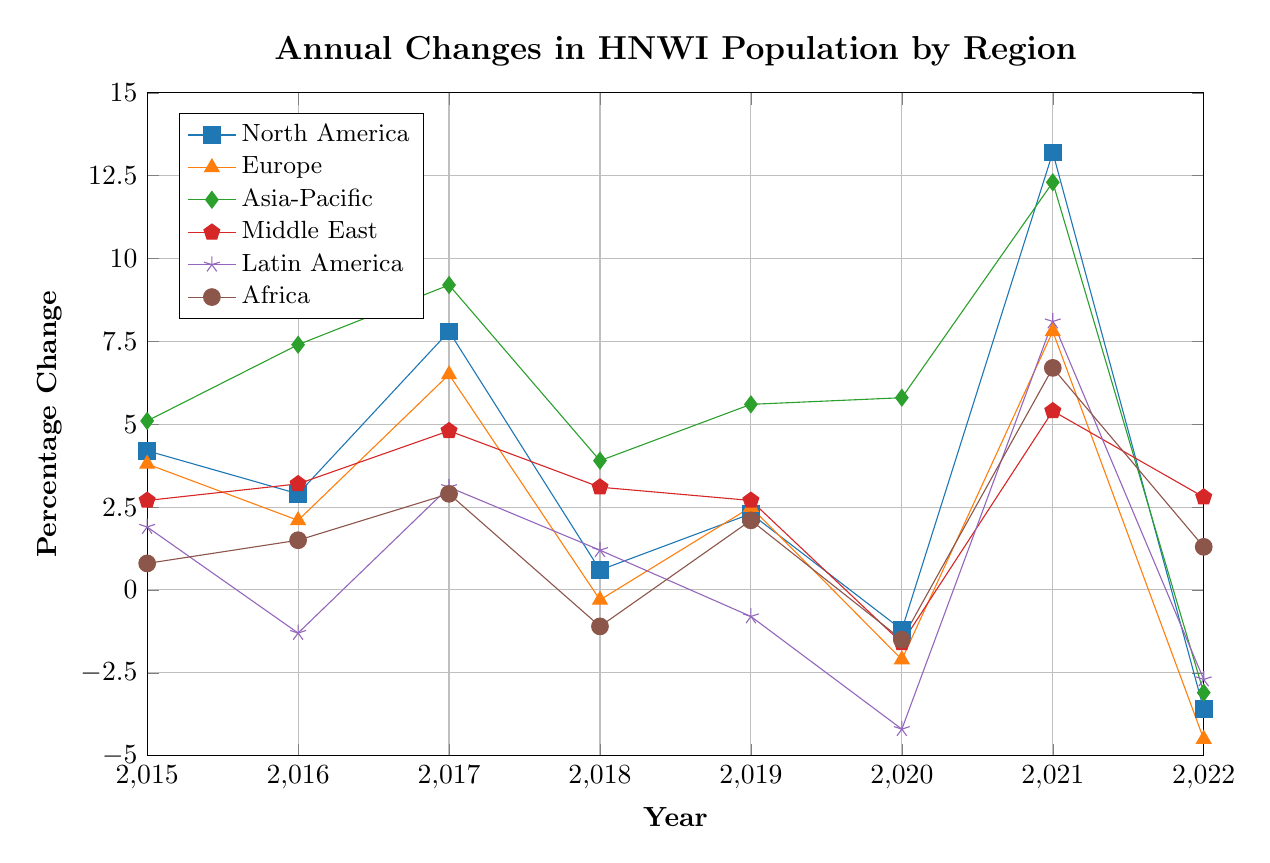Which region experienced the largest percentage decrease in HNWI population in 2022? By examining the data for each region in 2022, the largest percentage decrease can be identified. The values are: North America (-3.6%), Europe (-4.5%), Asia-Pacific (-3.1%), Middle East (2.8%), Latin America (-2.7%), Africa (1.3%). The largest decrease is seen in Europe.
Answer: Europe Which region had the highest percentage increase in HNWI population in 2021? Checking the data for 2021, the percentage increases for each region are: North America (13.2%), Europe (7.8%), Asia-Pacific (12.3%), Middle East (5.4%), Latin America (8.1%), Africa (6.7%). The highest increase is in North America.
Answer: North America What is the average percentage change in HNWI population for North America from 2015 to 2022? Adding up the percentage changes for North America from 2015 to 2022: 4.2% + 2.9% + 7.8% + 0.6% + 2.3% - 1.2% + 13.2% - 3.6% = 26.2%. There are 8 data points, so the average change is 26.2% / 8 = 3.275%.
Answer: 3.275% Which year saw the Asia-Pacific region having the lowest percentage change? Examining the percentage changes for Asia-Pacific from 2015 to 2022, the values are: 5.1%, 7.4%, 9.2%, 3.9%, 5.6%, 5.8%, 12.3%, -3.1%. The lowest percentage change is -3.1% in 2022.
Answer: 2022 In which year did Africa see a negative change in HNWI population? Checking each year's values for Africa: 2015 (0.8%), 2016 (1.5%), 2017 (2.9%), 2018 (-1.1%), 2019 (2.1%), 2020 (-1.5%), 2021 (6.7%), 2022 (1.3%), the years with negative values are 2018 and 2020.
Answer: 2018, 2020 Which two regions had a positive percentage change in 2020, and what were their respective changes? Looking at the data for 2020, the percentage changes are: North America (-1.2%), Europe (-2.1%), Asia-Pacific (5.8%), Middle East (-1.6%), Latin America (-4.2%), Africa (-1.5%). The regions with positive changes are Asia-Pacific and Africa with changes of 5.8% and -1.5% respectively.
Answer: Asia-Pacific (5.8%), Africa (1.3%) What was the percentage difference between the Middle East and Latin America in 2021? In 2021, the Middle East had a percentage change of 5.4%, and Latin America had 8.1%. The difference is 8.1% - 5.4% = 2.7%.
Answer: 2.7% Which region shows an overall increasing trend from 2015 to 2021? Examining the data for overall trends from 2015 to 2021: North America (4.2%, 2.9%, 7.8%, 0.6%, 2.3%, -1.2%, 13.2%), Europe (3.8%, 2.1%, 6.5%, -0.3%, 2.5%, -2.1%, 7.8%), Asia-Pacific (5.1%, 7.4%, 9.2%, 3.9%, 5.6%, 5.8%, 12.3%), Middle East (2.7%, 3.2%, 4.8%, 3.1%, 2.7%, -1.6%, 5.4%), Latin America (1.9%, -1.3%, 3.1%, 1.2%, -0.8%, -4.2%, 8.1%), Africa (0.8%, 1.5%, 2.9%, -1.1%, 2.1%, -1.5%, 6.7%). Asia-Pacific shows a consistent overall increase.
Answer: Asia-Pacific Between which consecutive years did Europe see the largest change in percentage? Referring to the annual changes for Europe: 3.8% (2015), 2.1% (2016), 6.5% (2017), -0.3% (2018), 2.5% (2019), -2.1% (2020), 7.8% (2021), -4.5% (2022), the largest change is observed between 2020 (-2.1%) and 2021 (7.8%), with a difference of 7.8% - (-2.1%) = 9.9%.
Answer: 2020 and 2021 